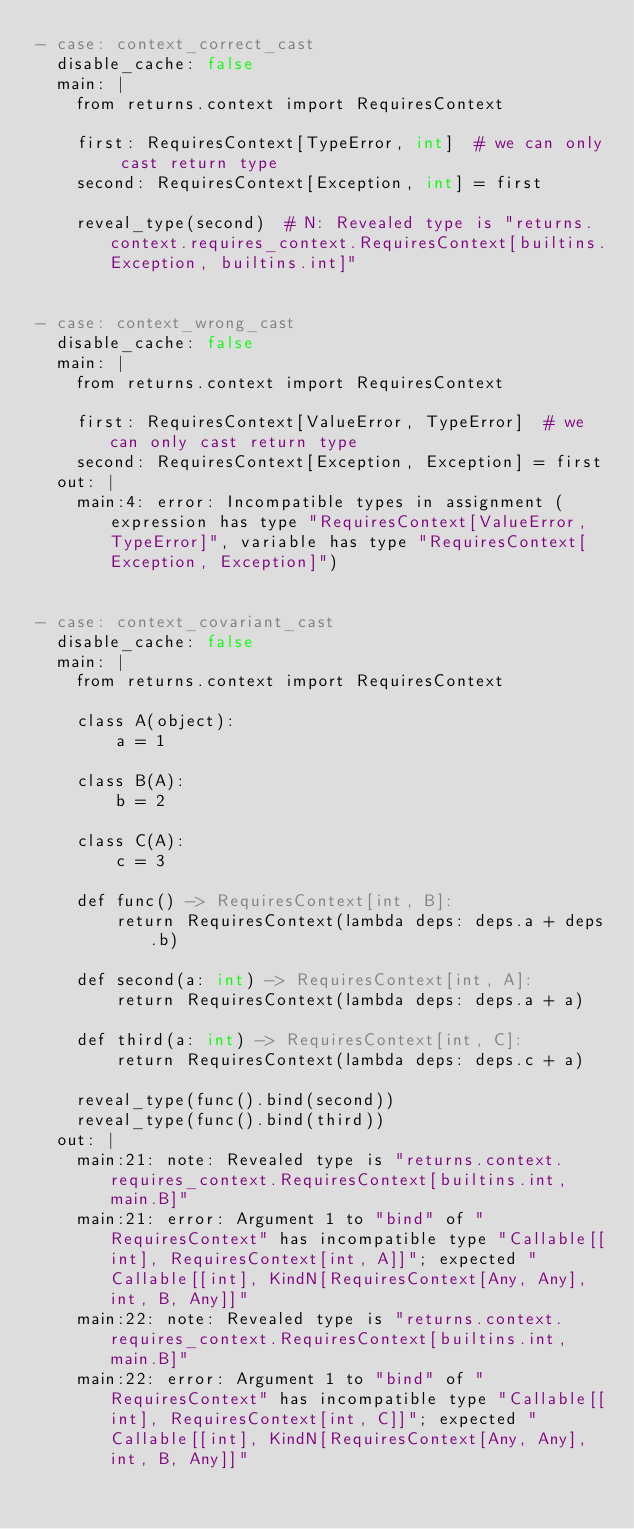<code> <loc_0><loc_0><loc_500><loc_500><_YAML_>- case: context_correct_cast
  disable_cache: false
  main: |
    from returns.context import RequiresContext

    first: RequiresContext[TypeError, int]  # we can only cast return type
    second: RequiresContext[Exception, int] = first

    reveal_type(second)  # N: Revealed type is "returns.context.requires_context.RequiresContext[builtins.Exception, builtins.int]"


- case: context_wrong_cast
  disable_cache: false
  main: |
    from returns.context import RequiresContext

    first: RequiresContext[ValueError, TypeError]  # we can only cast return type
    second: RequiresContext[Exception, Exception] = first
  out: |
    main:4: error: Incompatible types in assignment (expression has type "RequiresContext[ValueError, TypeError]", variable has type "RequiresContext[Exception, Exception]")


- case: context_covariant_cast
  disable_cache: false
  main: |
    from returns.context import RequiresContext

    class A(object):
        a = 1

    class B(A):
        b = 2

    class C(A):
        c = 3

    def func() -> RequiresContext[int, B]:
        return RequiresContext(lambda deps: deps.a + deps.b)

    def second(a: int) -> RequiresContext[int, A]:
        return RequiresContext(lambda deps: deps.a + a)

    def third(a: int) -> RequiresContext[int, C]:
        return RequiresContext(lambda deps: deps.c + a)

    reveal_type(func().bind(second))
    reveal_type(func().bind(third))
  out: |
    main:21: note: Revealed type is "returns.context.requires_context.RequiresContext[builtins.int, main.B]"
    main:21: error: Argument 1 to "bind" of "RequiresContext" has incompatible type "Callable[[int], RequiresContext[int, A]]"; expected "Callable[[int], KindN[RequiresContext[Any, Any], int, B, Any]]"
    main:22: note: Revealed type is "returns.context.requires_context.RequiresContext[builtins.int, main.B]"
    main:22: error: Argument 1 to "bind" of "RequiresContext" has incompatible type "Callable[[int], RequiresContext[int, C]]"; expected "Callable[[int], KindN[RequiresContext[Any, Any], int, B, Any]]"
</code> 